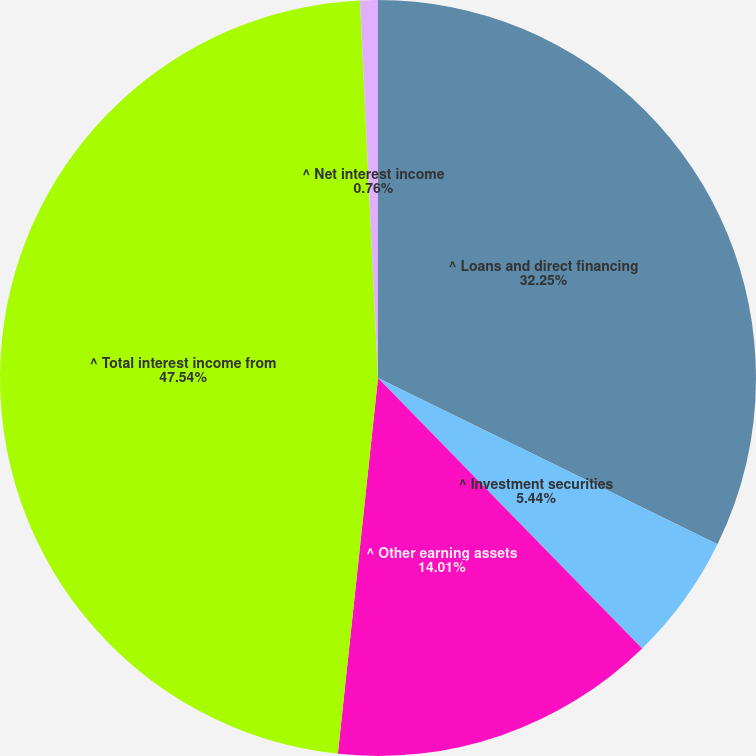Convert chart. <chart><loc_0><loc_0><loc_500><loc_500><pie_chart><fcel>^ Loans and direct financing<fcel>^ Investment securities<fcel>^ Other earning assets<fcel>^ Total interest income from<fcel>^ Net interest income<nl><fcel>32.25%<fcel>5.44%<fcel>14.01%<fcel>47.55%<fcel>0.76%<nl></chart> 